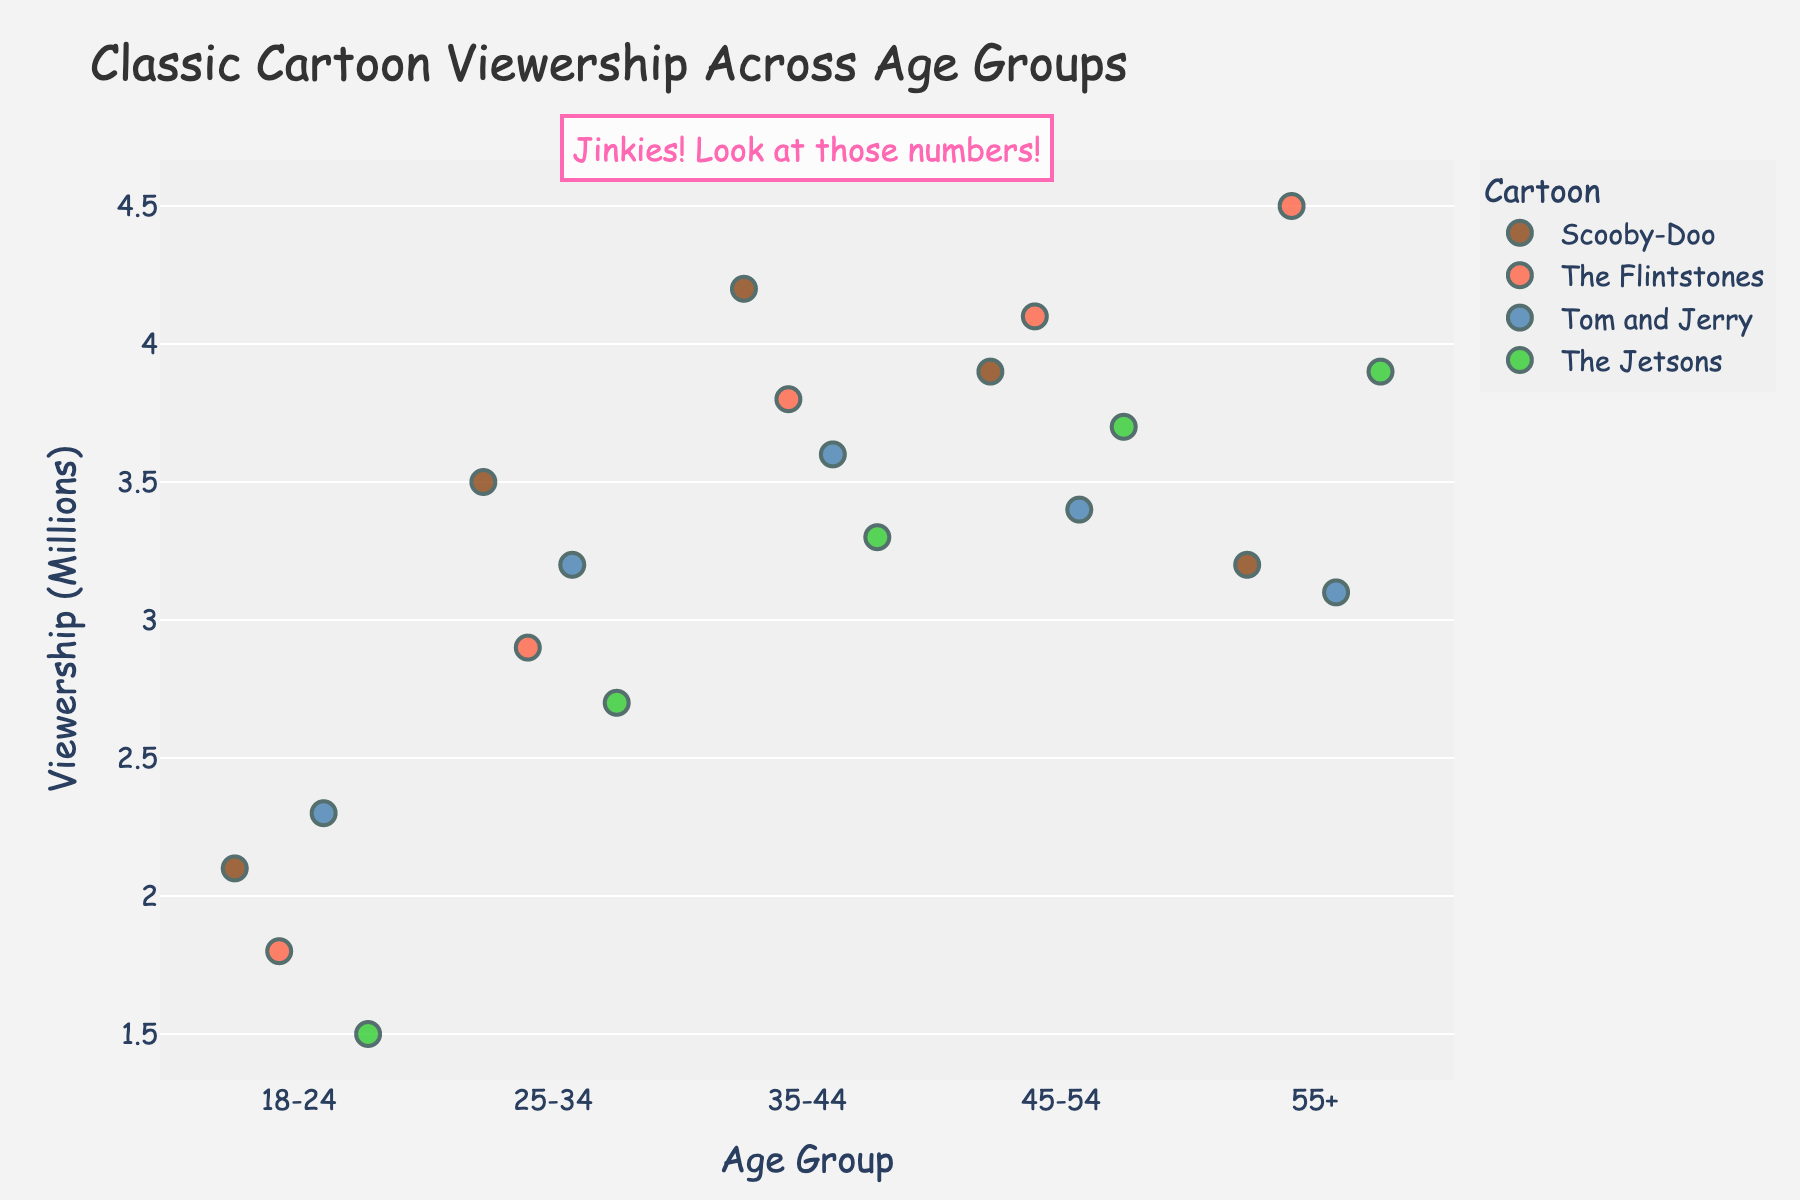What's the title of the figure? The title of the figure is typically displayed at the top. In this plot, it is "Classic Cartoon Viewership Across Age Groups"
Answer: Classic Cartoon Viewership Across Age Groups Which age group has the highest viewership for Scooby-Doo? By examining the dots for Scooby-Doo across all age groups, the highest value is found in the 35-44 age group at 4.2 million.
Answer: 35-44 What is the color used to represent The Flintstones? Each cartoon is represented by a specific color. The Flintstones is represented by a red tone.
Answer: Red How many age groups have viewership numbers exceeding 4 million for any cartoon? Identify all data points above 4 million across different age groups and count the distinct age groups: 35-44 (Scooby-Doo); 45-54 (The Flintstones); 55+ (The Flintstones).
Answer: 3 Compare the viewership numbers of The Jetsons and Tom and Jerry in the 45-54 age group. Which one is higher? By looking at the 45-54 age group, the viewership for The Jetsons is 3.7 million and for Tom and Jerry is 3.4 million. Hence, The Jetsons is higher.
Answer: The Jetsons Which cartoon has the most consistent viewership across different age groups? Consistency can be gauged by the spread of viewership numbers. Tom and Jerry has the smallest fluctuation, ranging from 3.1 to 3.6 million, indicating consistency.
Answer: Tom and Jerry What is the average viewership of The Flintstones across all age groups? Add up the viewership numbers for The Flintstones across all age groups (1.8, 2.9, 3.8, 4.1, 4.5) and divide by 5. The sum is 17.1 million, average = 17.1 / 5 = 3.42 million.
Answer: 3.42 million In which age group does Scooby-Doo have the lowest viewership? Examine the lowest point for Scooby-Doo across age groups, which is 2.1 million in the 18-24 age group.
Answer: 18-24 Is there a trend in viewership for Scooby-Doo as age increases? From the data points, viewership of Scooby-Doo first increases (from 2.1 to 4.2 million) and then decreases slightly (to 3.9 and 3.2 million). This trend shows a peak in the 35-44 age group and then a decline.
Answer: Peaks at 35-44, then declines 